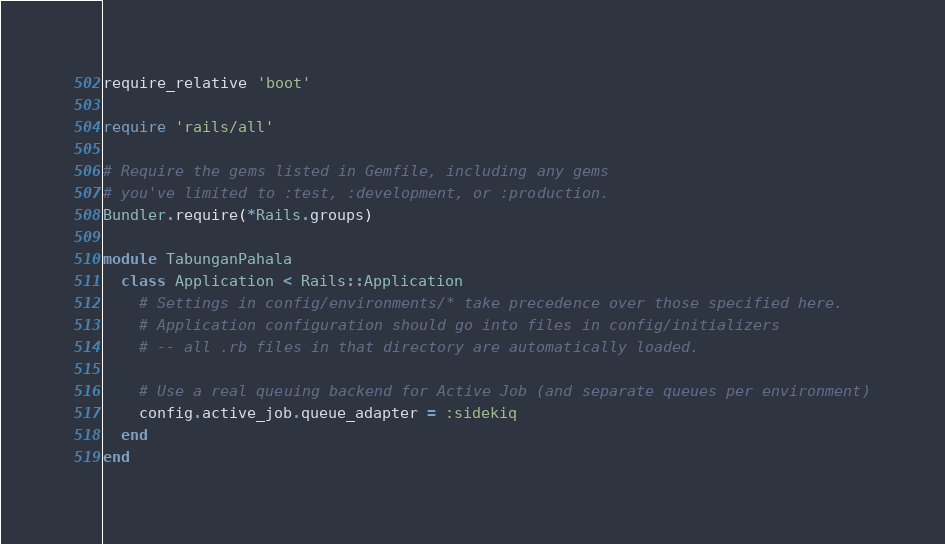Convert code to text. <code><loc_0><loc_0><loc_500><loc_500><_Ruby_>require_relative 'boot'

require 'rails/all'

# Require the gems listed in Gemfile, including any gems
# you've limited to :test, :development, or :production.
Bundler.require(*Rails.groups)

module TabunganPahala
  class Application < Rails::Application
    # Settings in config/environments/* take precedence over those specified here.
    # Application configuration should go into files in config/initializers
    # -- all .rb files in that directory are automatically loaded.

    # Use a real queuing backend for Active Job (and separate queues per environment)
    config.active_job.queue_adapter = :sidekiq
  end
end
</code> 